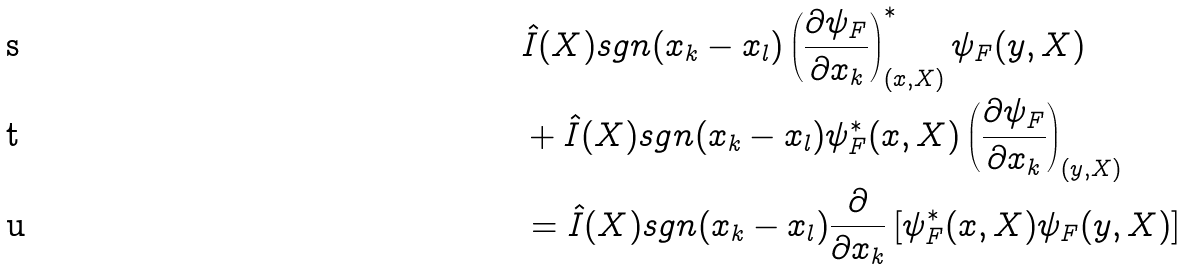<formula> <loc_0><loc_0><loc_500><loc_500>& \hat { I } ( X ) s g n ( x _ { k } - x _ { l } ) \left ( \frac { \partial \psi _ { F } } { \partial x _ { k } } \right ) ^ { * } _ { ( x , X ) } \psi _ { F } ( y , X ) \\ & + \hat { I } ( X ) s g n ( x _ { k } - x _ { l } ) \psi _ { F } ^ { * } ( x , X ) \left ( \frac { \partial \psi _ { F } } { \partial x _ { k } } \right ) _ { ( y , X ) } \\ & = \hat { I } ( X ) s g n ( x _ { k } - x _ { l } ) \frac { \partial } { \partial x _ { k } } \left [ \psi _ { F } ^ { * } ( x , X ) \psi _ { F } ( y , X ) \right ]</formula> 